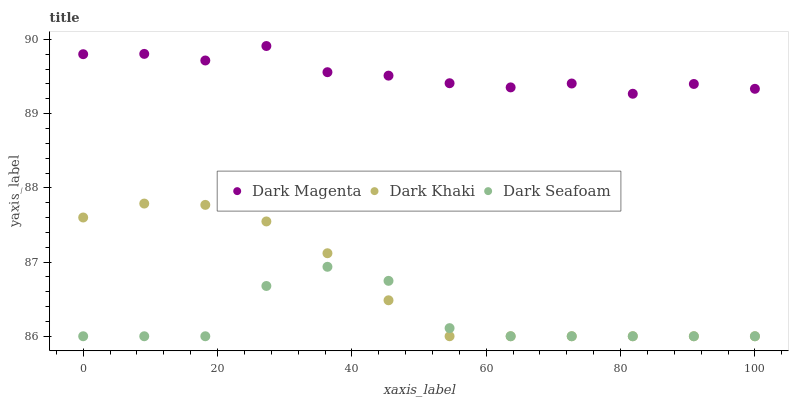Does Dark Seafoam have the minimum area under the curve?
Answer yes or no. Yes. Does Dark Magenta have the maximum area under the curve?
Answer yes or no. Yes. Does Dark Magenta have the minimum area under the curve?
Answer yes or no. No. Does Dark Seafoam have the maximum area under the curve?
Answer yes or no. No. Is Dark Khaki the smoothest?
Answer yes or no. Yes. Is Dark Seafoam the roughest?
Answer yes or no. Yes. Is Dark Magenta the smoothest?
Answer yes or no. No. Is Dark Magenta the roughest?
Answer yes or no. No. Does Dark Khaki have the lowest value?
Answer yes or no. Yes. Does Dark Magenta have the lowest value?
Answer yes or no. No. Does Dark Magenta have the highest value?
Answer yes or no. Yes. Does Dark Seafoam have the highest value?
Answer yes or no. No. Is Dark Khaki less than Dark Magenta?
Answer yes or no. Yes. Is Dark Magenta greater than Dark Khaki?
Answer yes or no. Yes. Does Dark Seafoam intersect Dark Khaki?
Answer yes or no. Yes. Is Dark Seafoam less than Dark Khaki?
Answer yes or no. No. Is Dark Seafoam greater than Dark Khaki?
Answer yes or no. No. Does Dark Khaki intersect Dark Magenta?
Answer yes or no. No. 